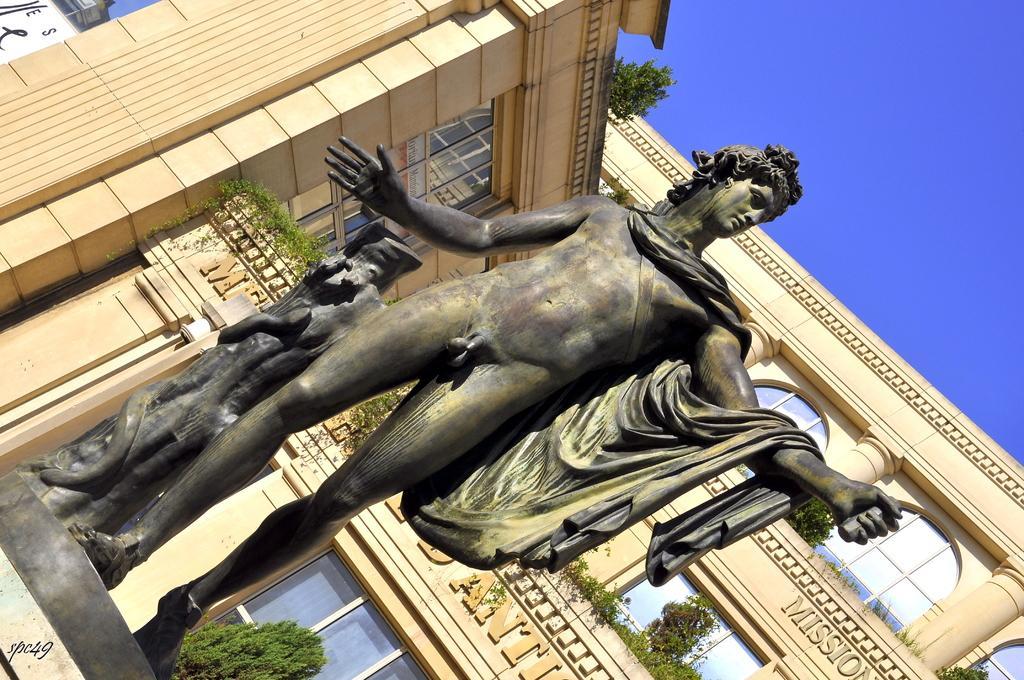Can you describe this image briefly? In the picture we can see a sculpture of the man standing on the stone and behind the sculpture we can see the building with windows and plants near it and on the top of the building we can see the part of the sky. 